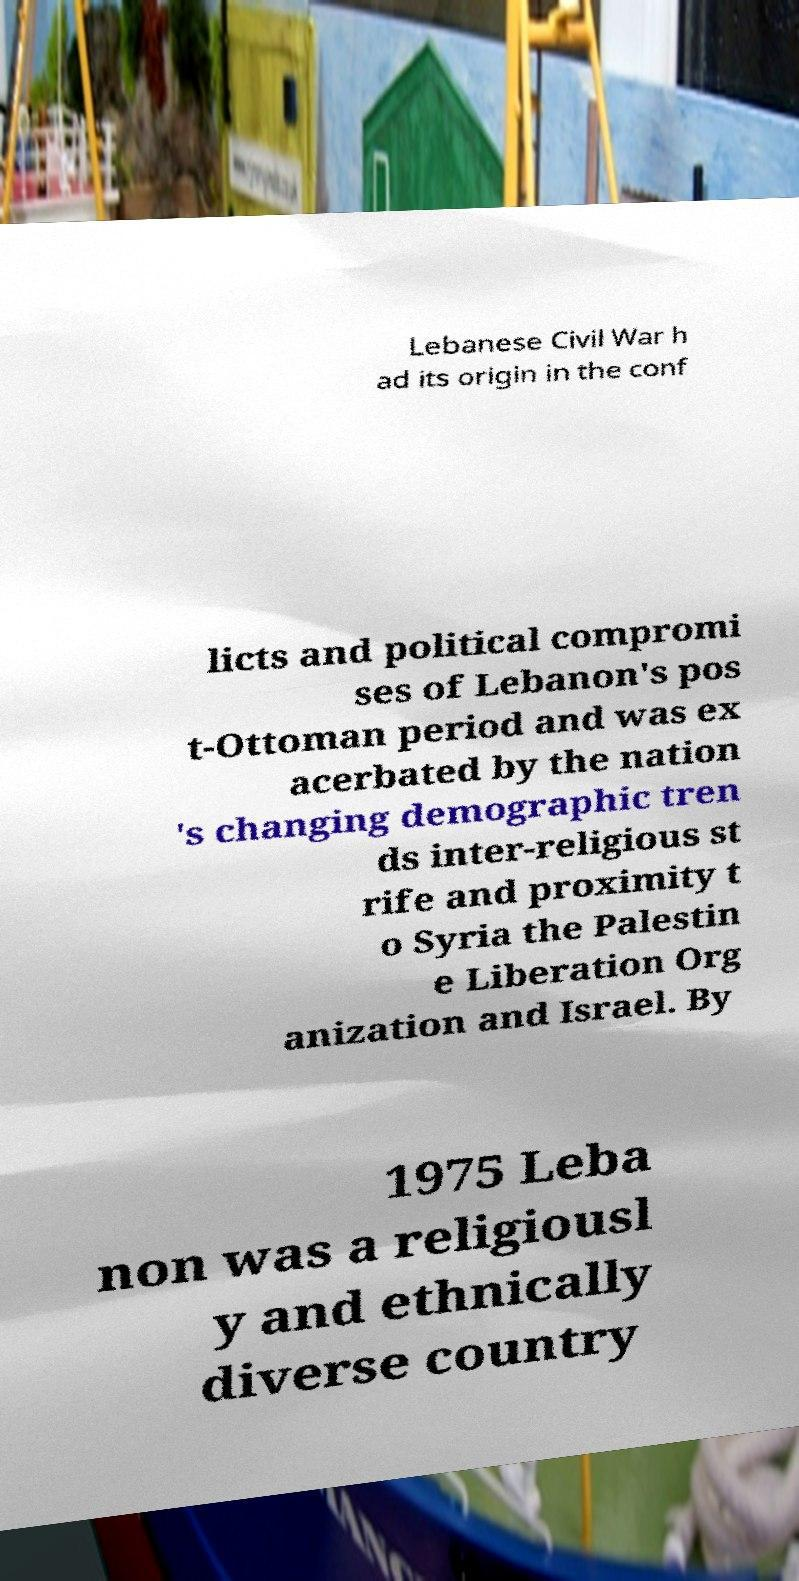Could you extract and type out the text from this image? Lebanese Civil War h ad its origin in the conf licts and political compromi ses of Lebanon's pos t-Ottoman period and was ex acerbated by the nation 's changing demographic tren ds inter-religious st rife and proximity t o Syria the Palestin e Liberation Org anization and Israel. By 1975 Leba non was a religiousl y and ethnically diverse country 